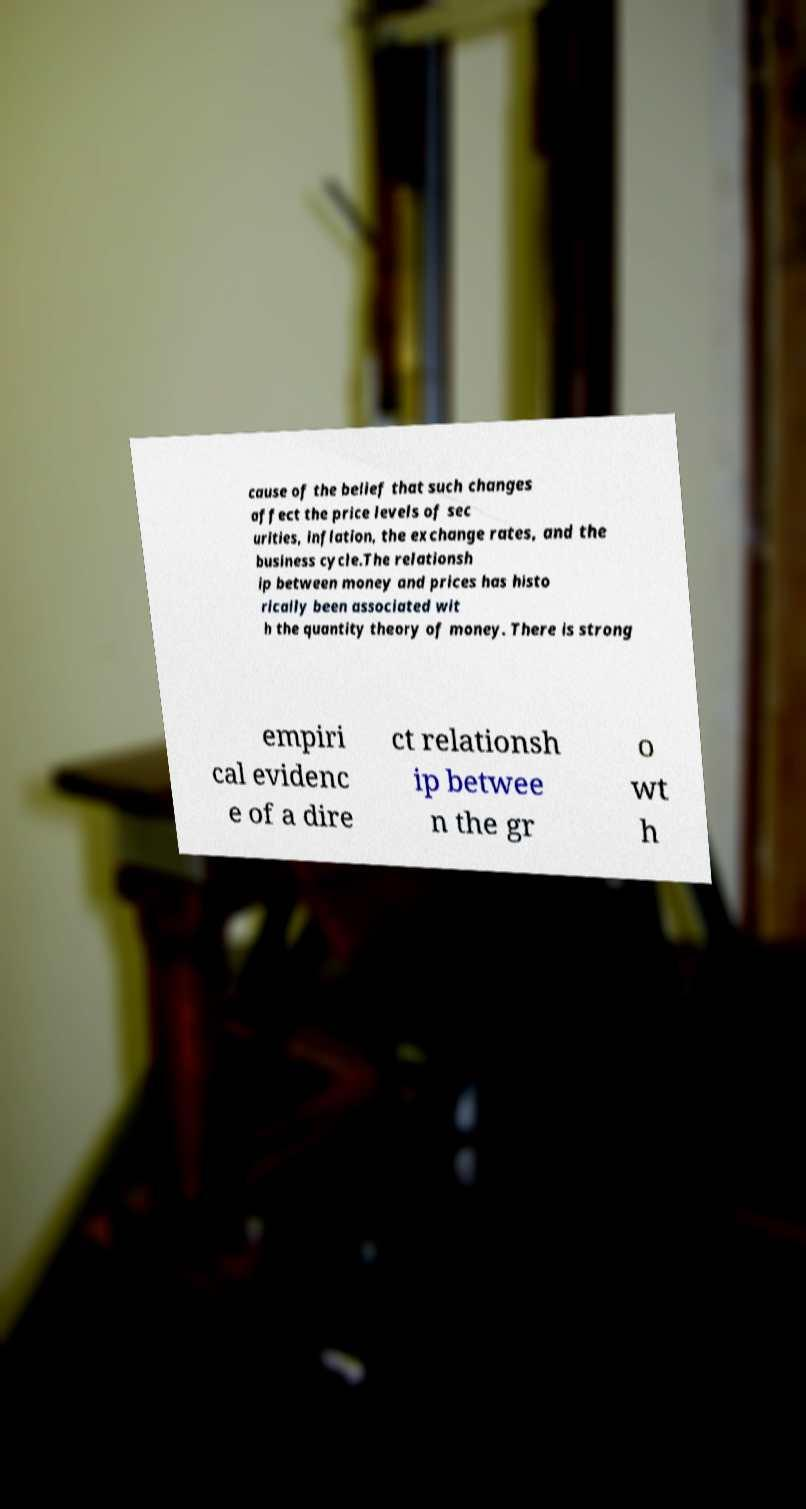I need the written content from this picture converted into text. Can you do that? cause of the belief that such changes affect the price levels of sec urities, inflation, the exchange rates, and the business cycle.The relationsh ip between money and prices has histo rically been associated wit h the quantity theory of money. There is strong empiri cal evidenc e of a dire ct relationsh ip betwee n the gr o wt h 